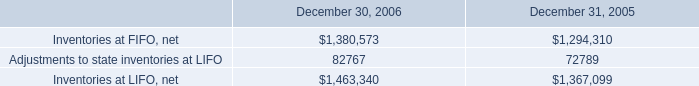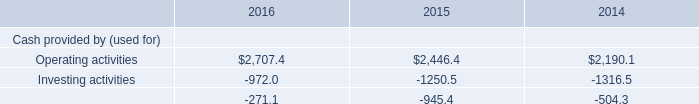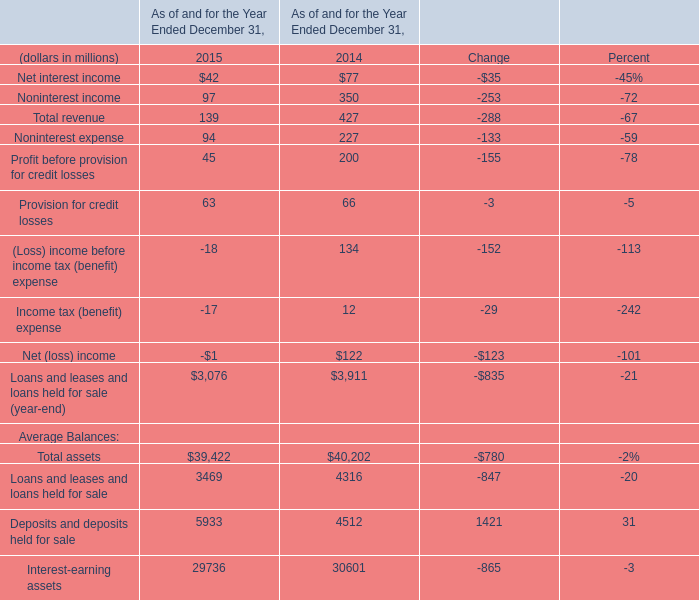What is the total amount of Inventories at FIFO, net of December 30, 2006, and Operating activities of 2015 ? 
Computations: (1380573.0 + 2446.4)
Answer: 1383019.4. 